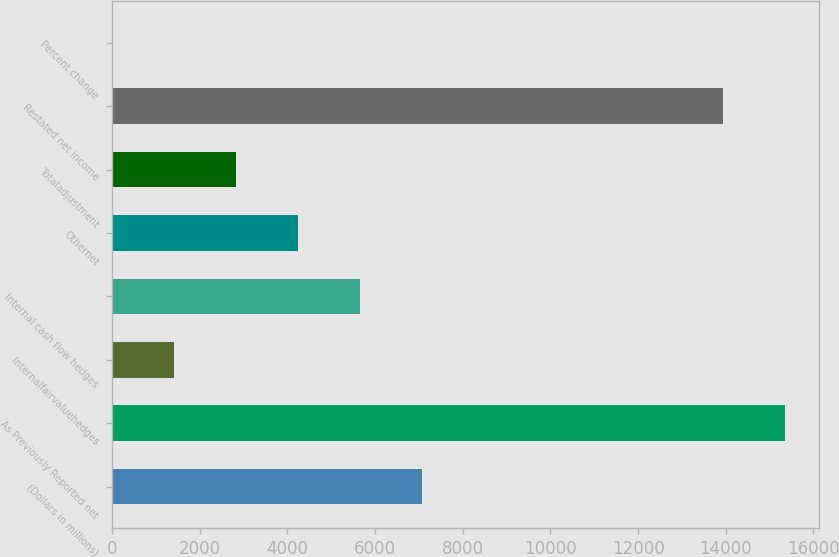Convert chart to OTSL. <chart><loc_0><loc_0><loc_500><loc_500><bar_chart><fcel>(Dollars in millions)<fcel>As Previously Reported net<fcel>Internalfairvaluehedges<fcel>Internal cash flow hedges<fcel>Othernet<fcel>Totaladjustment<fcel>Restated net income<fcel>Percent change<nl><fcel>7072.2<fcel>15361.2<fcel>1415.56<fcel>5658.04<fcel>4243.88<fcel>2829.72<fcel>13947<fcel>1.4<nl></chart> 